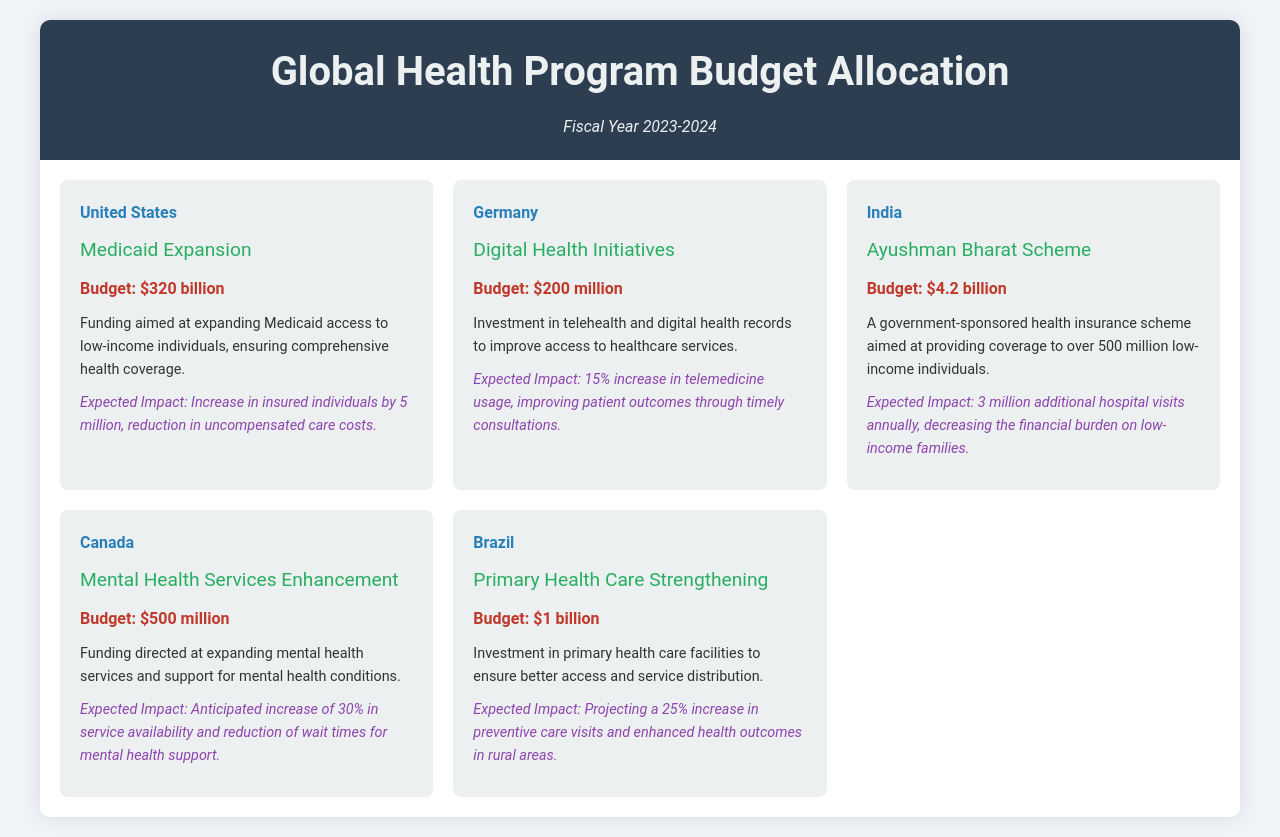What is the budget for Medicaid Expansion in the United States? The budget for Medicaid Expansion is provided in the section about the United States, which states it is $320 billion.
Answer: $320 billion What is the expected impact of the Ayushman Bharat Scheme in India? The expected impact is mentioned under the program details for India and states it is 3 million additional hospital visits annually.
Answer: 3 million What country is investing in Digital Health Initiatives? The country that is investing in Digital Health Initiatives is stated in the document as Germany.
Answer: Germany How much budget is allocated for Mental Health Services Enhancement in Canada? The budget for Mental Health Services Enhancement is specified as $500 million in the program details for Canada.
Answer: $500 million What percentage increase in preventive care visits is projected for Brazil's Primary Health Care Strengthening? The document states that there is a projected 25% increase in preventive care visits for Brazil's program.
Answer: 25% What is a key feature of the Ayushman Bharat Scheme in India? A key feature of the Ayushman Bharat Scheme, as stated in the document, is it aims at providing coverage to over 500 million low-income individuals.
Answer: Coverage to over 500 million low-income individuals Which country is expected to increase telemedicine usage by 15%? The document specifies that Germany is expected to increase telemedicine usage by 15%.
Answer: Germany What is the budget for Primary Health Care Strengthening in Brazil? The budget for Primary Health Care Strengthening is detailed in the program section for Brazil as $1 billion.
Answer: $1 billion 